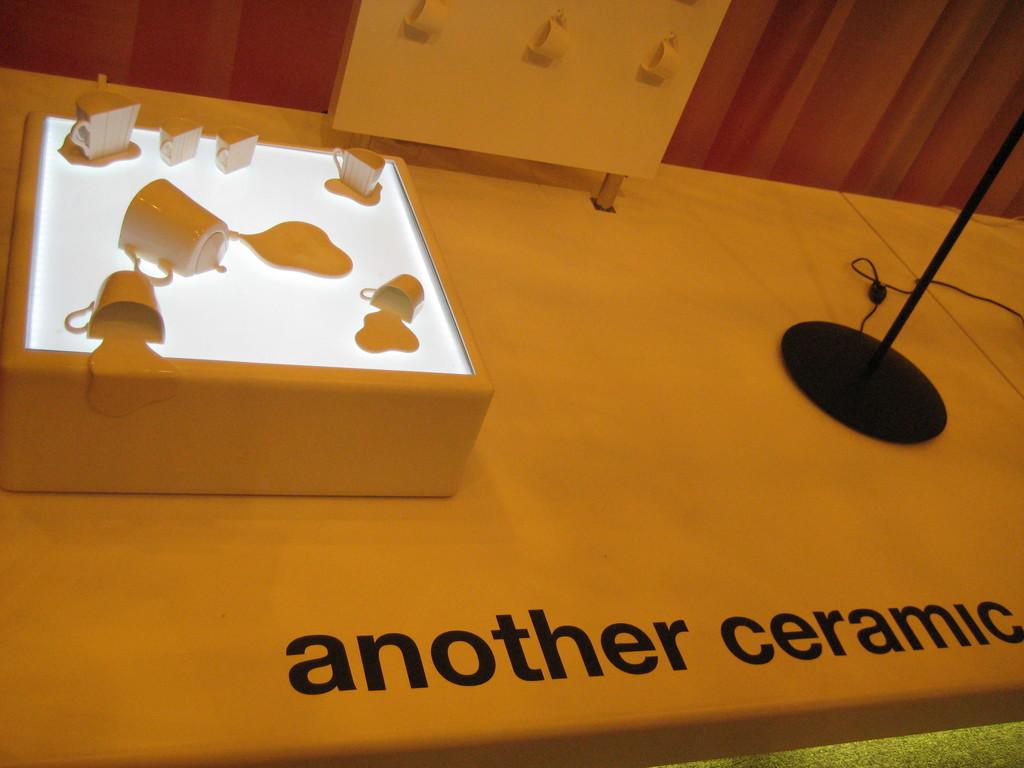What are these made out of?
Your answer should be very brief. Ceramic. What is the word in black before ceramic?
Your answer should be very brief. Another. 